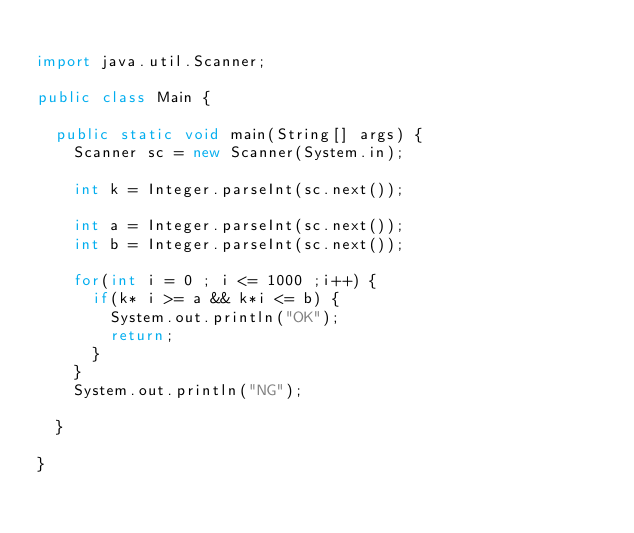<code> <loc_0><loc_0><loc_500><loc_500><_Java_>
import java.util.Scanner;

public class Main {

	public static void main(String[] args) {
		Scanner sc = new Scanner(System.in);
		
		int k = Integer.parseInt(sc.next());
		
		int a = Integer.parseInt(sc.next());
		int b = Integer.parseInt(sc.next());
		
		for(int i = 0 ; i <= 1000 ;i++) {
			if(k* i >= a && k*i <= b) {
				System.out.println("OK");
				return;
			}
		}
		System.out.println("NG");

	}

}
</code> 